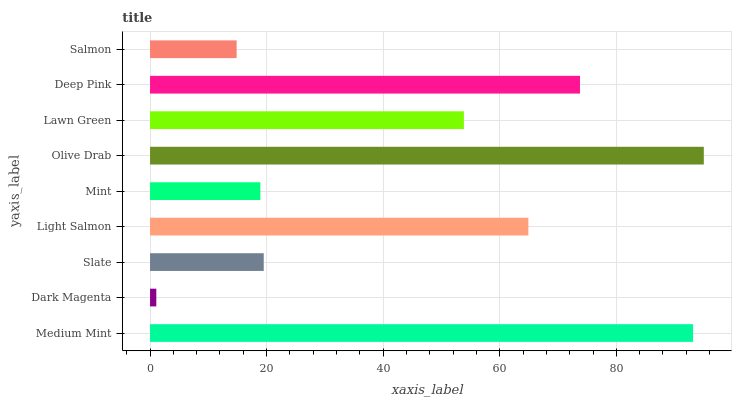Is Dark Magenta the minimum?
Answer yes or no. Yes. Is Olive Drab the maximum?
Answer yes or no. Yes. Is Slate the minimum?
Answer yes or no. No. Is Slate the maximum?
Answer yes or no. No. Is Slate greater than Dark Magenta?
Answer yes or no. Yes. Is Dark Magenta less than Slate?
Answer yes or no. Yes. Is Dark Magenta greater than Slate?
Answer yes or no. No. Is Slate less than Dark Magenta?
Answer yes or no. No. Is Lawn Green the high median?
Answer yes or no. Yes. Is Lawn Green the low median?
Answer yes or no. Yes. Is Medium Mint the high median?
Answer yes or no. No. Is Mint the low median?
Answer yes or no. No. 